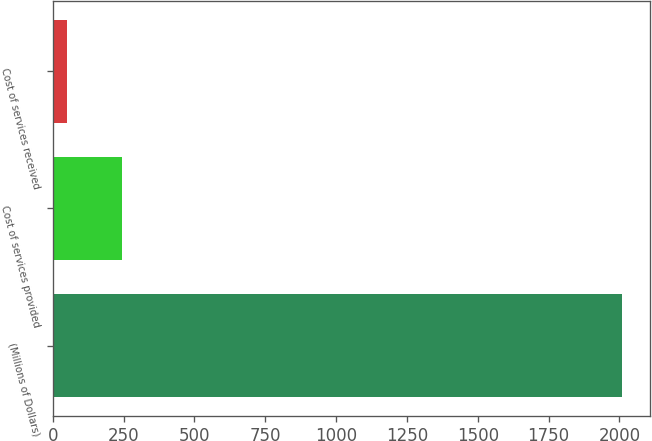Convert chart. <chart><loc_0><loc_0><loc_500><loc_500><bar_chart><fcel>(Millions of Dollars)<fcel>Cost of services provided<fcel>Cost of services received<nl><fcel>2008<fcel>245.8<fcel>50<nl></chart> 